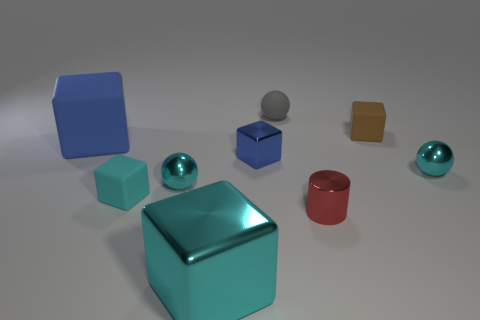There is a matte thing that is the same color as the big metal object; what is its shape?
Provide a short and direct response. Cube. There is a gray matte ball; is it the same size as the cyan metal object right of the big shiny thing?
Your answer should be very brief. Yes. What shape is the big thing to the right of the large block that is left of the small cyan ball on the left side of the tiny red metallic object?
Offer a very short reply. Cube. Is the number of tiny cyan objects less than the number of blue metal objects?
Provide a succinct answer. No. Are there any small shiny cylinders on the right side of the small brown matte block?
Give a very brief answer. No. The object that is both behind the blue metal cube and in front of the tiny brown matte thing has what shape?
Your answer should be compact. Cube. Are there any brown objects of the same shape as the large cyan thing?
Offer a terse response. Yes. Is the size of the matte object left of the tiny cyan cube the same as the sphere that is on the right side of the small metallic cylinder?
Make the answer very short. No. Are there more brown objects than big brown metal cylinders?
Your answer should be very brief. Yes. What number of red things have the same material as the small brown cube?
Make the answer very short. 0. 